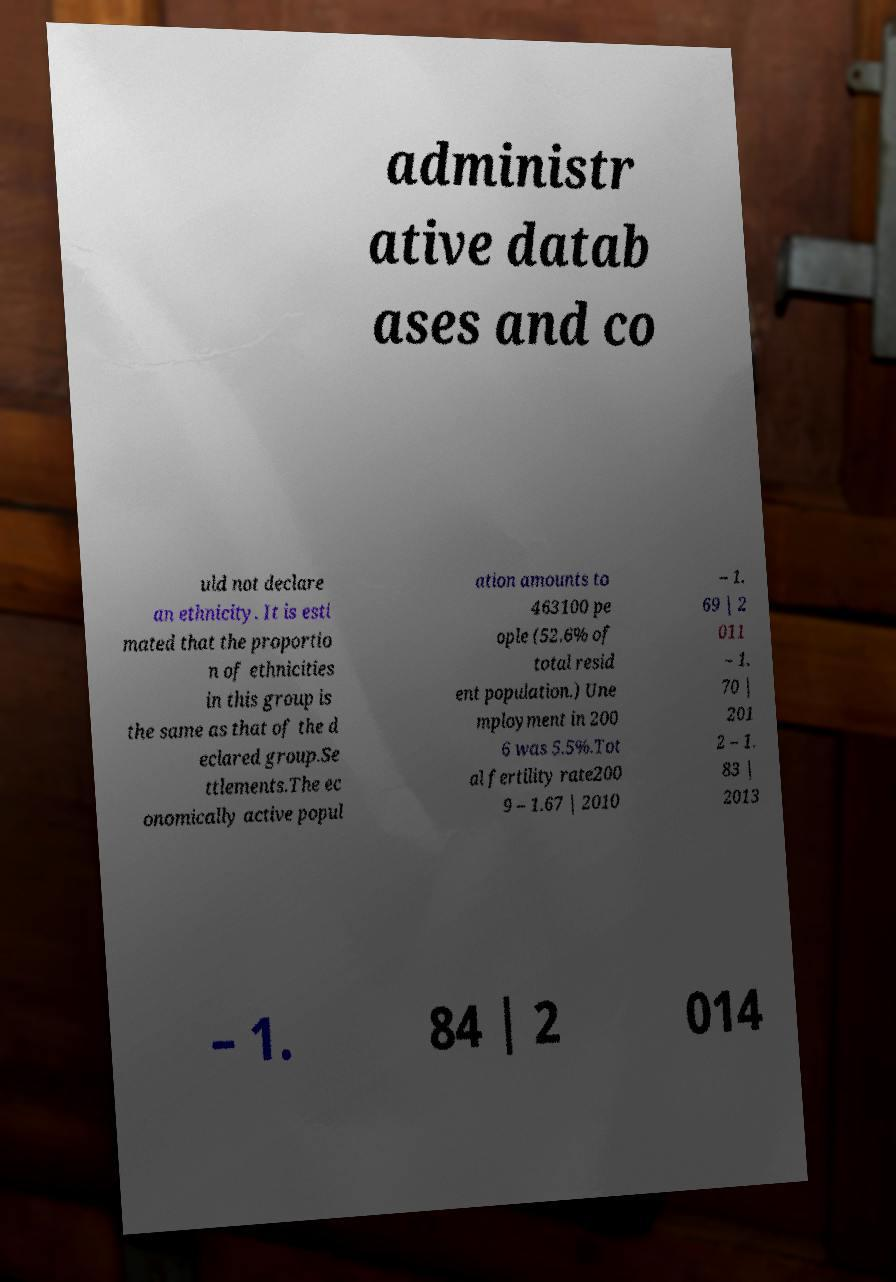There's text embedded in this image that I need extracted. Can you transcribe it verbatim? administr ative datab ases and co uld not declare an ethnicity. It is esti mated that the proportio n of ethnicities in this group is the same as that of the d eclared group.Se ttlements.The ec onomically active popul ation amounts to 463100 pe ople (52.6% of total resid ent population.) Une mployment in 200 6 was 5.5%.Tot al fertility rate200 9 – 1.67 | 2010 – 1. 69 | 2 011 – 1. 70 | 201 2 – 1. 83 | 2013 – 1. 84 | 2 014 